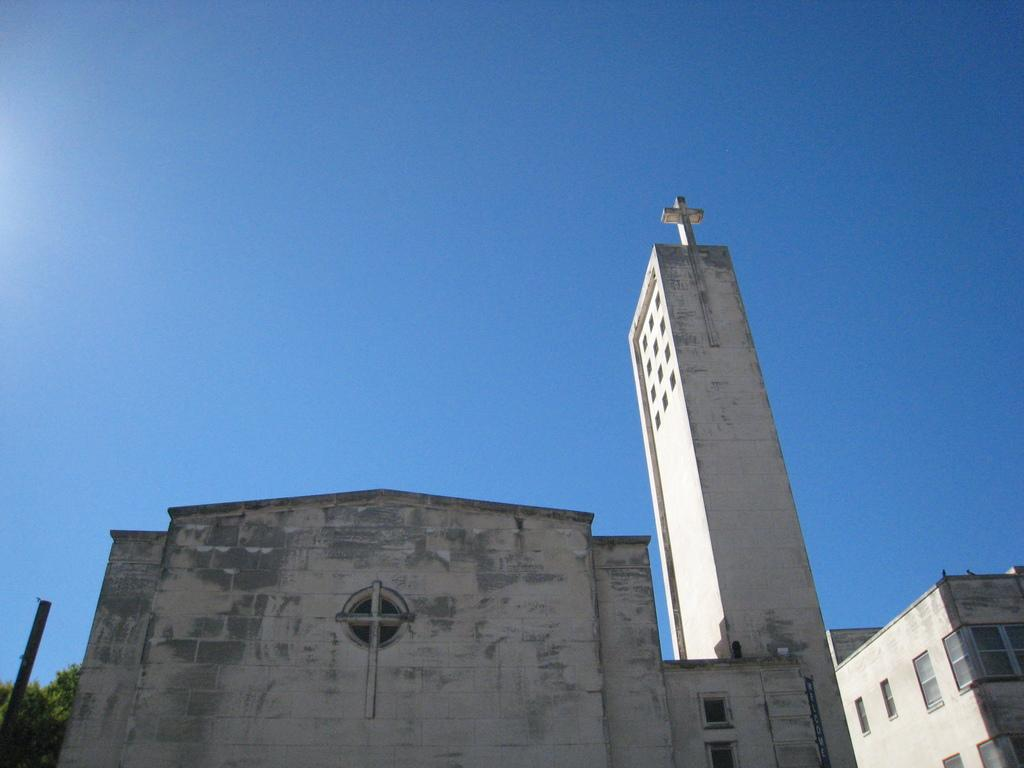What types of structures are located at the bottom of the image? There are buildings with windows and a tower at the bottom of the image. What else can be seen at the bottom of the image? There are trees at the bottom of the image. What is the color of the sky in the background of the image? The background of the image contains a blue sky. Where is the cemetery located in the image? There is no cemetery present in the image. What type of frame surrounds the image? The image does not have a frame; it is a digital representation. 